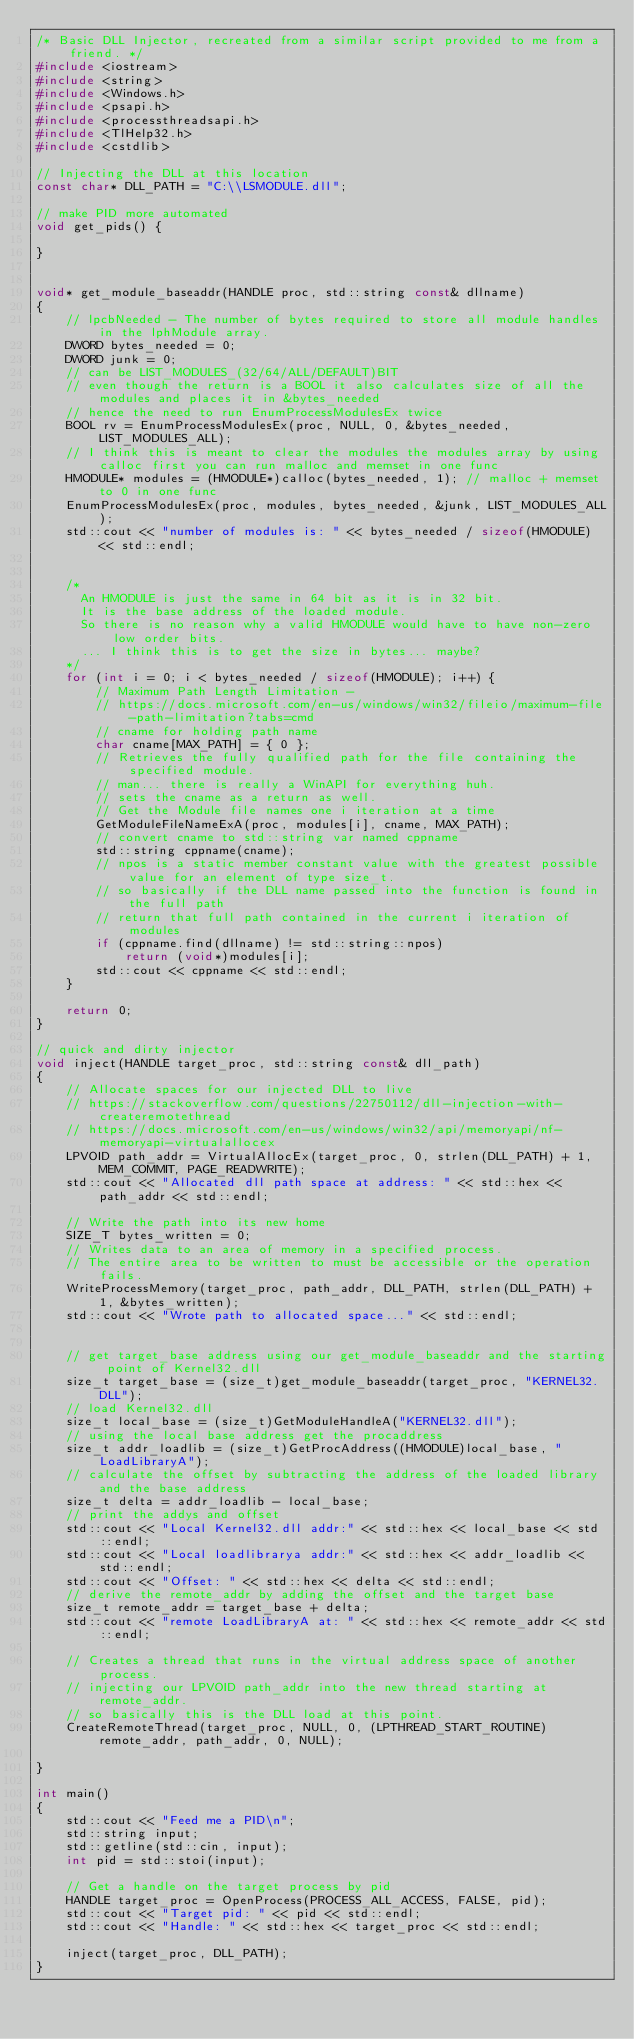<code> <loc_0><loc_0><loc_500><loc_500><_C++_>/* Basic DLL Injector, recreated from a similar script provided to me from a friend. */
#include <iostream>
#include <string>
#include <Windows.h>
#include <psapi.h>
#include <processthreadsapi.h>
#include <TlHelp32.h>
#include <cstdlib>

// Injecting the DLL at this location
const char* DLL_PATH = "C:\\LSMODULE.dll";

// make PID more automated
void get_pids() {

}


void* get_module_baseaddr(HANDLE proc, std::string const& dllname)
{
    // lpcbNeeded - The number of bytes required to store all module handles in the lphModule array.
    DWORD bytes_needed = 0;
    DWORD junk = 0;
    // can be LIST_MODULES_(32/64/ALL/DEFAULT)BIT 
    // even though the return is a BOOL it also calculates size of all the modules and places it in &bytes_needed 
    // hence the need to run EnumProcessModulesEx twice
    BOOL rv = EnumProcessModulesEx(proc, NULL, 0, &bytes_needed, LIST_MODULES_ALL);
    // I think this is meant to clear the modules the modules array by using calloc first you can run malloc and memset in one func
    HMODULE* modules = (HMODULE*)calloc(bytes_needed, 1); // malloc + memset to 0 in one func
    EnumProcessModulesEx(proc, modules, bytes_needed, &junk, LIST_MODULES_ALL);
    std::cout << "number of modules is: " << bytes_needed / sizeof(HMODULE) << std::endl;


    /*
      An HMODULE is just the same in 64 bit as it is in 32 bit.
      It is the base address of the loaded module.
      So there is no reason why a valid HMODULE would have to have non-zero low order bits.
      ... I think this is to get the size in bytes... maybe?
    */
    for (int i = 0; i < bytes_needed / sizeof(HMODULE); i++) {
        // Maximum Path Length Limitation - 
        // https://docs.microsoft.com/en-us/windows/win32/fileio/maximum-file-path-limitation?tabs=cmd
        // cname for holding path name
        char cname[MAX_PATH] = { 0 };
        // Retrieves the fully qualified path for the file containing the specified module.
        // man... there is really a WinAPI for everything huh.
        // sets the cname as a return as well.
        // Get the Module file names one i iteration at a time
        GetModuleFileNameExA(proc, modules[i], cname, MAX_PATH);
        // convert cname to std::string var named cppname
        std::string cppname(cname);
        // npos is a static member constant value with the greatest possible value for an element of type size_t.
        // so basically if the DLL name passed into the function is found in the full path 
        // return that full path contained in the current i iteration of modules
        if (cppname.find(dllname) != std::string::npos)
            return (void*)modules[i];
        std::cout << cppname << std::endl;
    }

    return 0;
}

// quick and dirty injector
void inject(HANDLE target_proc, std::string const& dll_path)
{
    // Allocate spaces for our injected DLL to live
    // https://stackoverflow.com/questions/22750112/dll-injection-with-createremotethread
    // https://docs.microsoft.com/en-us/windows/win32/api/memoryapi/nf-memoryapi-virtualallocex
    LPVOID path_addr = VirtualAllocEx(target_proc, 0, strlen(DLL_PATH) + 1, MEM_COMMIT, PAGE_READWRITE);
    std::cout << "Allocated dll path space at address: " << std::hex << path_addr << std::endl;

    // Write the path into its new home
    SIZE_T bytes_written = 0;
    // Writes data to an area of memory in a specified process. 
    // The entire area to be written to must be accessible or the operation fails.
    WriteProcessMemory(target_proc, path_addr, DLL_PATH, strlen(DLL_PATH) + 1, &bytes_written);
    std::cout << "Wrote path to allocated space..." << std::endl;


    // get target_base address using our get_module_baseaddr and the starting point of Kernel32.dll 
    size_t target_base = (size_t)get_module_baseaddr(target_proc, "KERNEL32.DLL");
    // load Kernel32.dll
    size_t local_base = (size_t)GetModuleHandleA("KERNEL32.dll");
    // using the local base address get the procaddress
    size_t addr_loadlib = (size_t)GetProcAddress((HMODULE)local_base, "LoadLibraryA");
    // calculate the offset by subtracting the address of the loaded library and the base address
    size_t delta = addr_loadlib - local_base;
    // print the addys and offset
    std::cout << "Local Kernel32.dll addr:" << std::hex << local_base << std::endl;
    std::cout << "Local loadlibrarya addr:" << std::hex << addr_loadlib << std::endl;
    std::cout << "Offset: " << std::hex << delta << std::endl;
    // derive the remote_addr by adding the offset and the target base
    size_t remote_addr = target_base + delta;
    std::cout << "remote LoadLibraryA at: " << std::hex << remote_addr << std::endl;

    // Creates a thread that runs in the virtual address space of another process.
    // injecting our LPVOID path_addr into the new thread starting at remote_addr.
    // so basically this is the DLL load at this point.
    CreateRemoteThread(target_proc, NULL, 0, (LPTHREAD_START_ROUTINE)remote_addr, path_addr, 0, NULL);

}

int main()
{
    std::cout << "Feed me a PID\n";
    std::string input;
    std::getline(std::cin, input);
    int pid = std::stoi(input);

    // Get a handle on the target process by pid
    HANDLE target_proc = OpenProcess(PROCESS_ALL_ACCESS, FALSE, pid);
    std::cout << "Target pid: " << pid << std::endl;
    std::cout << "Handle: " << std::hex << target_proc << std::endl;

    inject(target_proc, DLL_PATH);
}</code> 